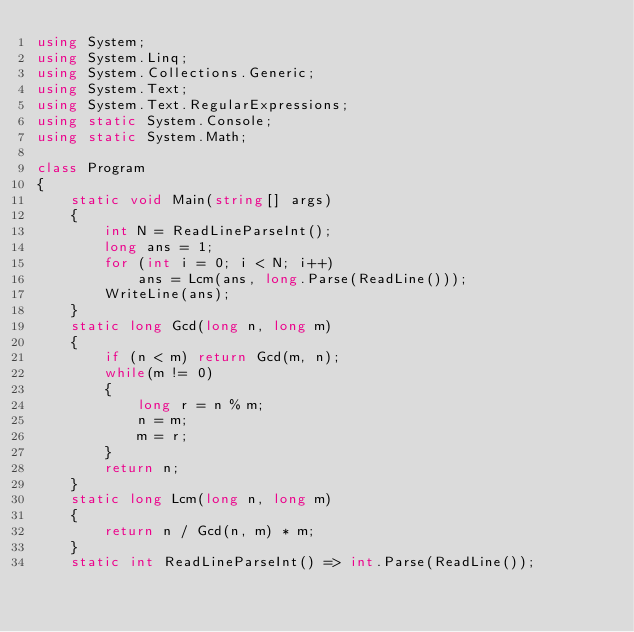Convert code to text. <code><loc_0><loc_0><loc_500><loc_500><_C#_>using System;
using System.Linq;
using System.Collections.Generic;
using System.Text;
using System.Text.RegularExpressions;
using static System.Console;
using static System.Math;

class Program
{
    static void Main(string[] args)
    {
        int N = ReadLineParseInt();
        long ans = 1;
        for (int i = 0; i < N; i++)
            ans = Lcm(ans, long.Parse(ReadLine()));
        WriteLine(ans);
    }
    static long Gcd(long n, long m)
    {
        if (n < m) return Gcd(m, n);
        while(m != 0)
        {
            long r = n % m;
            n = m;
            m = r;
        }
        return n;
    }
    static long Lcm(long n, long m)
    {
        return n / Gcd(n, m) * m;
    }
    static int ReadLineParseInt() => int.Parse(ReadLine());</code> 